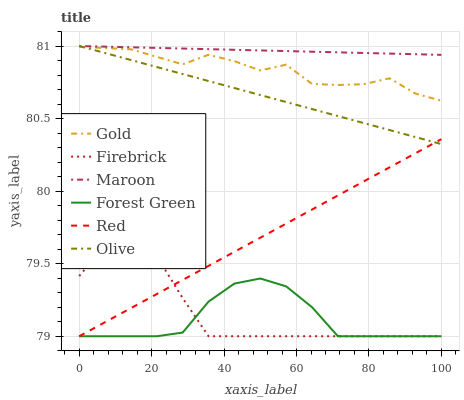Does Forest Green have the minimum area under the curve?
Answer yes or no. Yes. Does Maroon have the maximum area under the curve?
Answer yes or no. Yes. Does Firebrick have the minimum area under the curve?
Answer yes or no. No. Does Firebrick have the maximum area under the curve?
Answer yes or no. No. Is Maroon the smoothest?
Answer yes or no. Yes. Is Gold the roughest?
Answer yes or no. Yes. Is Firebrick the smoothest?
Answer yes or no. No. Is Firebrick the roughest?
Answer yes or no. No. Does Firebrick have the lowest value?
Answer yes or no. Yes. Does Maroon have the lowest value?
Answer yes or no. No. Does Olive have the highest value?
Answer yes or no. Yes. Does Firebrick have the highest value?
Answer yes or no. No. Is Firebrick less than Olive?
Answer yes or no. Yes. Is Maroon greater than Red?
Answer yes or no. Yes. Does Forest Green intersect Firebrick?
Answer yes or no. Yes. Is Forest Green less than Firebrick?
Answer yes or no. No. Is Forest Green greater than Firebrick?
Answer yes or no. No. Does Firebrick intersect Olive?
Answer yes or no. No. 